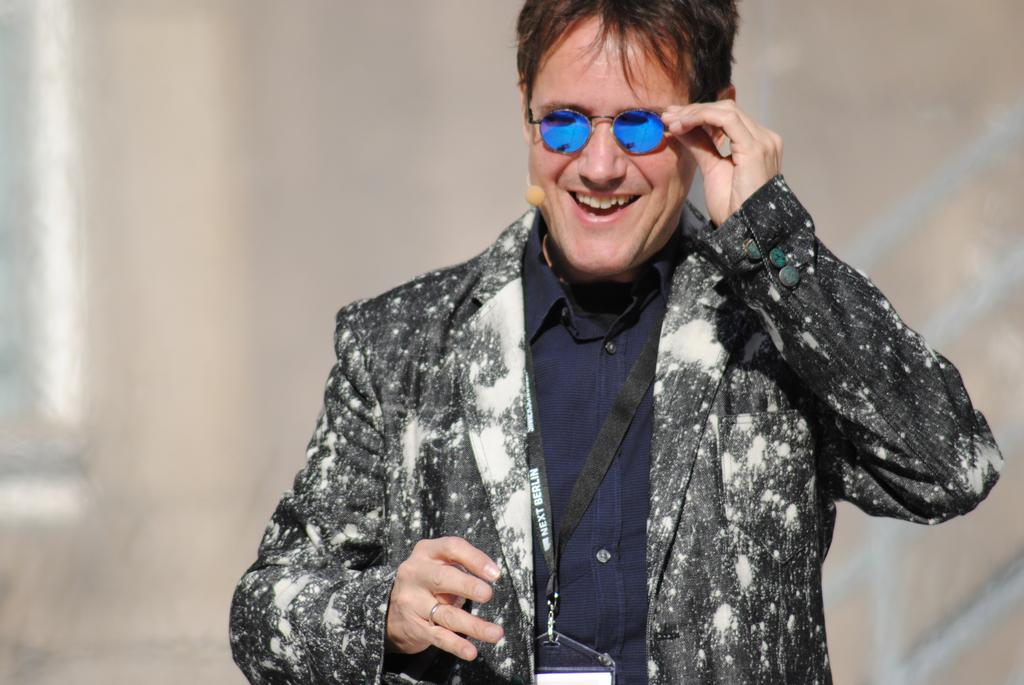What is the main subject of the image? There is a person in the image. What is the person's facial expression? The person is smiling. What accessory is the person wearing? The person is wearing goggles. Can you describe the background of the image? The background of the image is blurry. How many balloons are tied to the person's wrist in the image? There are no balloons present in the image. What type of home is visible in the background of the image? There is no home visible in the image; the background is blurry. 